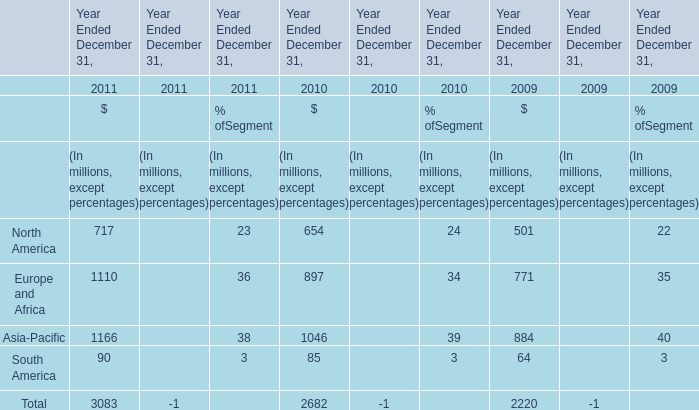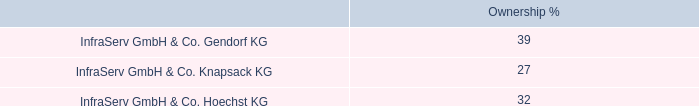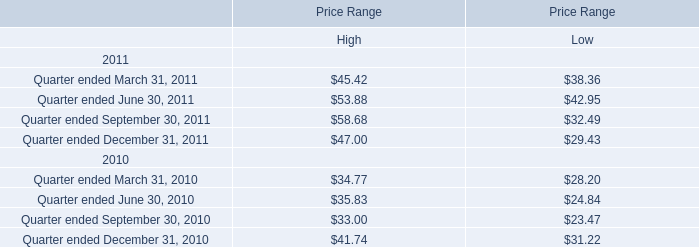What is the average growth rate of North America between 2010 and 2011? 
Computations: ((((654 - 501) / 501) + ((717 - 654) / 654)) / 2)
Answer: 0.20086. 